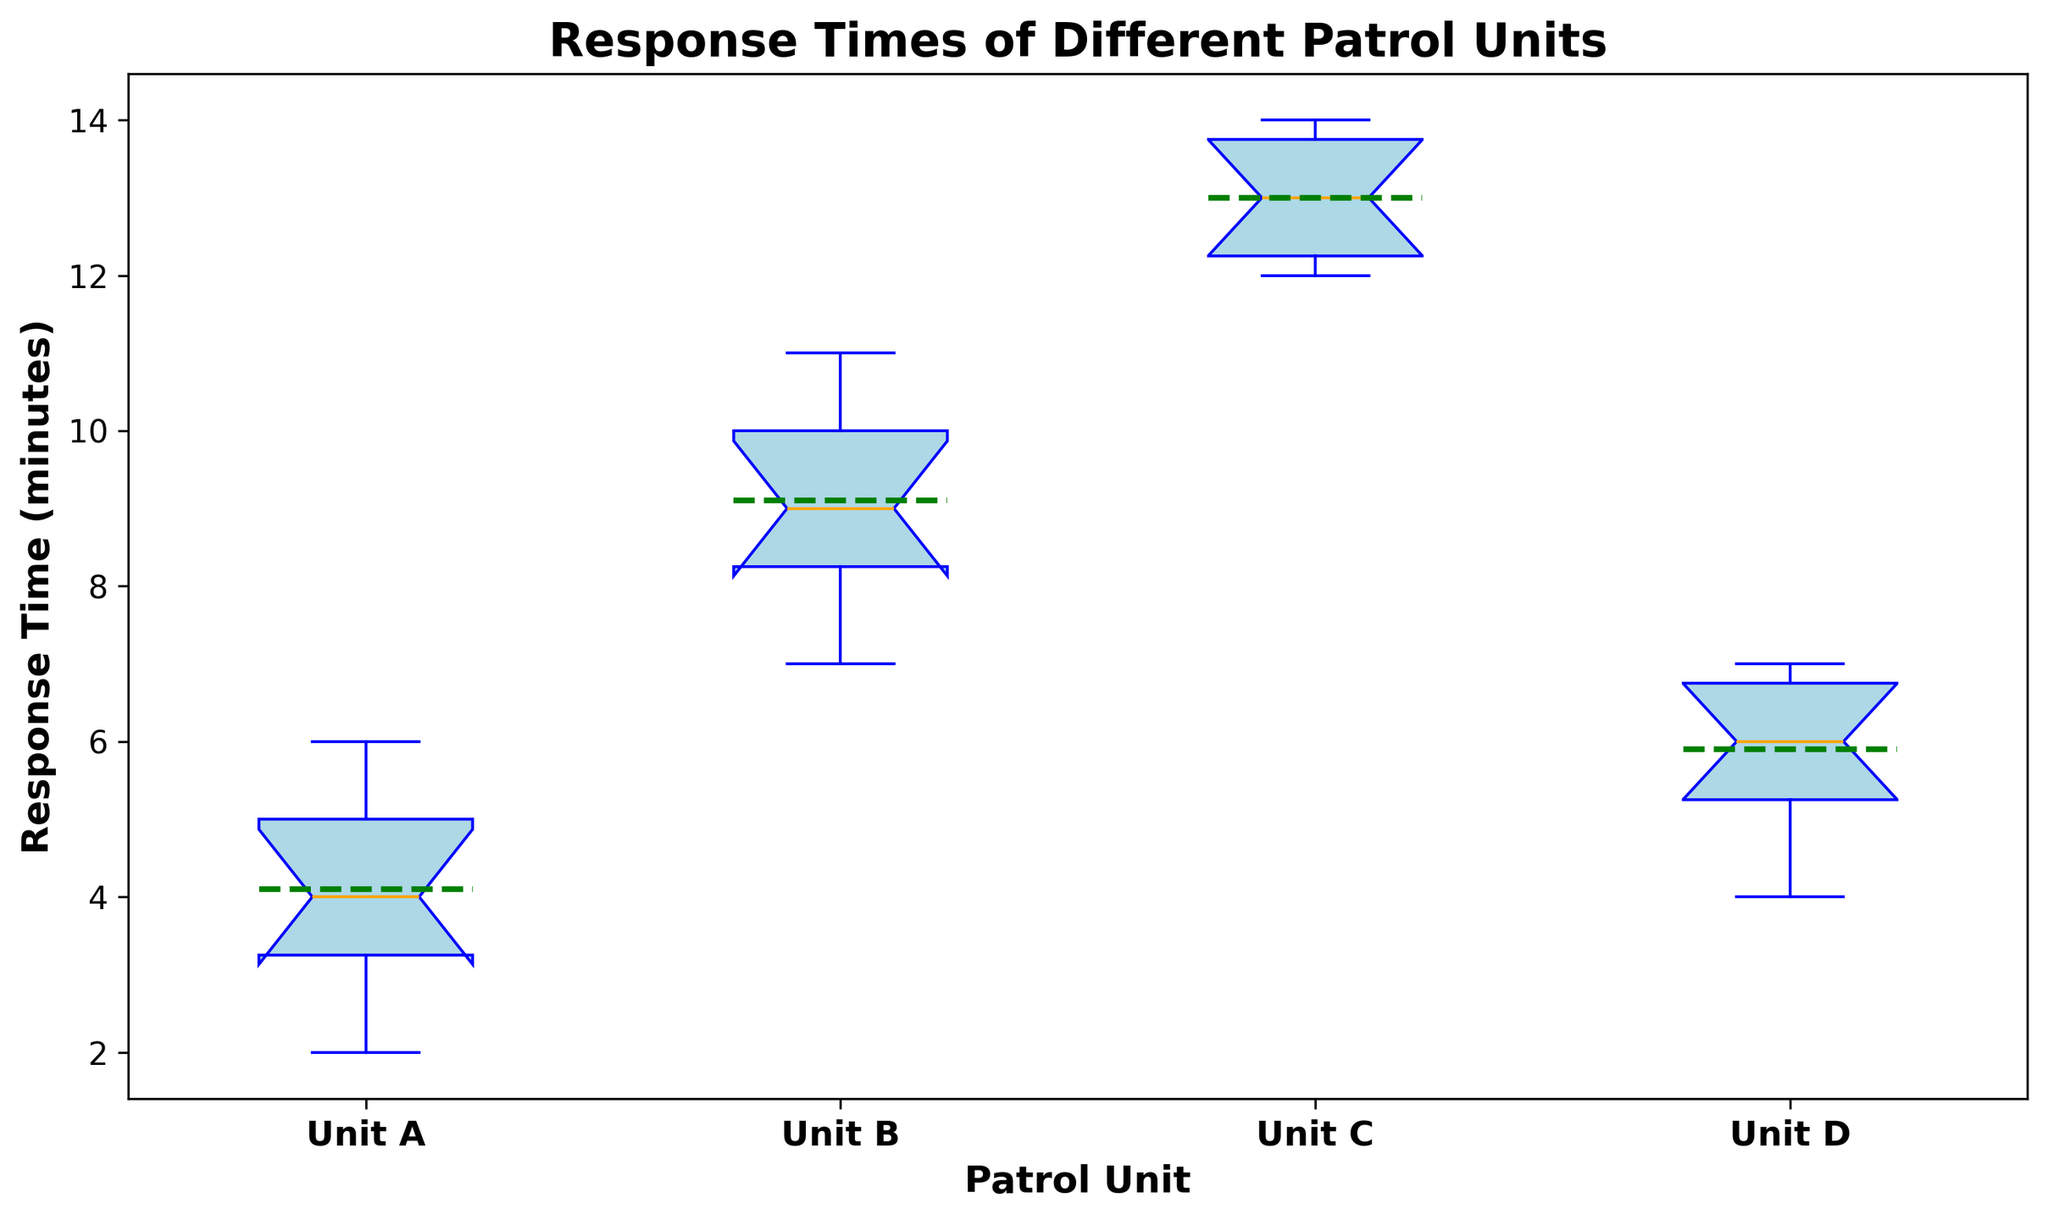How many outliers are there for each patrol unit? There are red markers in the box plot that represent the outliers. By counting the red markers for each patrol unit, we see that Unit A has no outliers, Unit B has no outliers, Unit C has no outliers, and Unit D has no outliers.
Answer: None Which patrol unit has the highest median response time? To determine this, look at the thick orange line inside each box (representing the median). The unit with the highest median is Unit C.
Answer: Unit C What is the median response time for Unit D? The thick orange line inside the box for Unit D indicates the median response time. For Unit D, it is 8 minutes.
Answer: 8 minutes Between Unit A and Unit B, which has a larger range of response times? The range can be determined by the distance between the top and bottom whiskers. For Unit A, the range is from 4 to 8 (4 minutes), and for Unit B, it’s from 9 to 13 (4 minutes). Both units have the same range of 4 minutes.
Answer: Same range Which unit has the smallest mean response time? The green line inside each box represents the mean. By comparing the green lines, Unit A has the smallest mean response time.
Answer: Unit A What is the lower quartile for Unit B? The lower quartile (Q1) is represented by the bottom edge of the box. For Unit B, Q1 is 10 minutes.
Answer: 10 minutes Which unit has the highest response time recorded, and what is that time? The highest response time is indicated by the top whisker or outlier. Unit C has the highest recorded response time at 16 minutes.
Answer: Unit C, 16 minutes Compare the interquartile range (IQR) between Unit C and Unit D. Which is larger? The IQR is the difference between the upper quartile (Q3) and the lower quartile (Q1). For Unit C, Q3 is 16 and Q1 is 14, so IQR = 16 - 14 = 2. For Unit D, Q3 is 9 and Q1 is 7, so IQR = 9 - 7 = 2. Both units have the same IQR.
Answer: Same IQR Is there a unit that has both its mean and median higher than any of Unit D's response times? Look at the green (mean) and thick orange (median) lines for each unit. For Unit C, both the mean and median are higher than 9 minutes (the highest response time for Unit D).
Answer: Unit C 